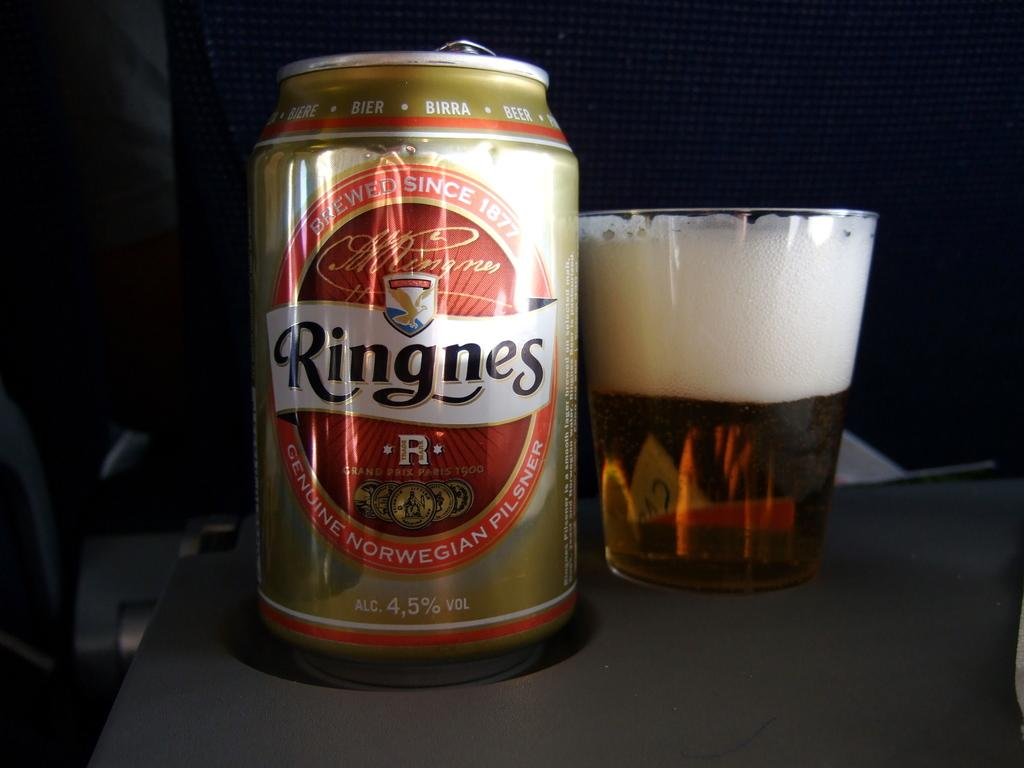<image>
Give a short and clear explanation of the subsequent image. a can of ringnes genuine norwegian pilsner sitting next to a glass of it 